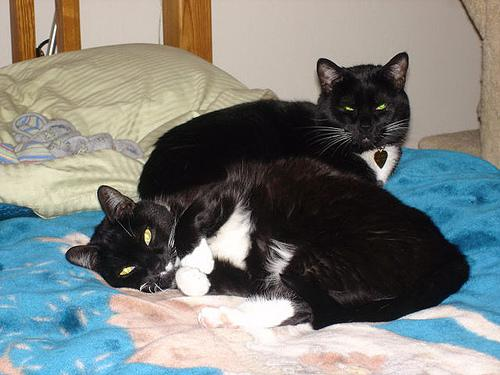Question: what color are the cats?
Choices:
A. Black and white.
B. Calico.
C. Gray.
D. Yellow.
Answer with the letter. Answer: A Question: what are the cats doing?
Choices:
A. Playing.
B. Eating.
C. Sleeping.
D. Laying.
Answer with the letter. Answer: D Question: what are the cats looking towards?
Choices:
A. Camera.
B. Door.
C. Food.
D. Bowl.
Answer with the letter. Answer: A Question: who is next to the cat?
Choices:
A. Mom.
B. Dad.
C. My brother.
D. No one.
Answer with the letter. Answer: D Question: where was the photo taken?
Choices:
A. On a couch.
B. In front of a bed.
C. On a chair.
D. On a bed.
Answer with the letter. Answer: D 